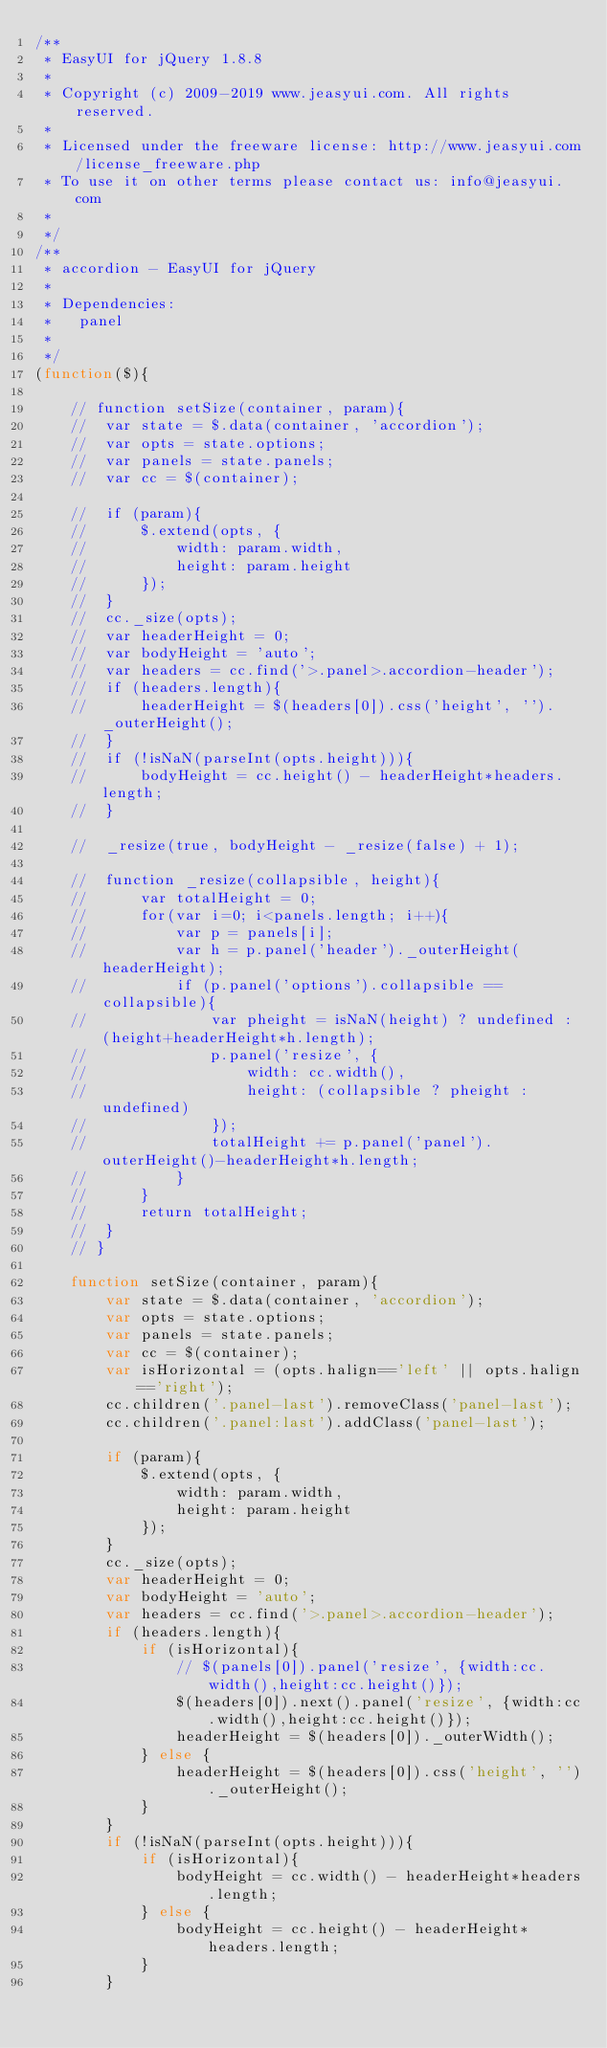<code> <loc_0><loc_0><loc_500><loc_500><_JavaScript_>/**
 * EasyUI for jQuery 1.8.8
 * 
 * Copyright (c) 2009-2019 www.jeasyui.com. All rights reserved.
 *
 * Licensed under the freeware license: http://www.jeasyui.com/license_freeware.php
 * To use it on other terms please contact us: info@jeasyui.com
 *
 */
/**
 * accordion - EasyUI for jQuery
 * 
 * Dependencies:
 * 	 panel
 * 
 */
(function($){
	
	// function setSize(container, param){
	// 	var state = $.data(container, 'accordion');
	// 	var opts = state.options;
	// 	var panels = state.panels;
	// 	var cc = $(container);
		
	// 	if (param){
	// 		$.extend(opts, {
	// 			width: param.width,
	// 			height: param.height
	// 		});
	// 	}
	// 	cc._size(opts);
	// 	var headerHeight = 0;
	// 	var bodyHeight = 'auto';
	// 	var headers = cc.find('>.panel>.accordion-header');
	// 	if (headers.length){
	// 		headerHeight = $(headers[0]).css('height', '')._outerHeight();
	// 	}
	// 	if (!isNaN(parseInt(opts.height))){
	// 		bodyHeight = cc.height() - headerHeight*headers.length;
	// 	}
		
	// 	_resize(true, bodyHeight - _resize(false) + 1);
		
	// 	function _resize(collapsible, height){
	// 		var totalHeight = 0;
	// 		for(var i=0; i<panels.length; i++){
	// 			var p = panels[i];
	// 			var h = p.panel('header')._outerHeight(headerHeight);
	// 			if (p.panel('options').collapsible == collapsible){
	// 				var pheight = isNaN(height) ? undefined : (height+headerHeight*h.length);
	// 				p.panel('resize', {
	// 					width: cc.width(),
	// 					height: (collapsible ? pheight : undefined)
	// 				});
	// 				totalHeight += p.panel('panel').outerHeight()-headerHeight*h.length;
	// 			}
	// 		}
	// 		return totalHeight;
	// 	}
	// }

	function setSize(container, param){
		var state = $.data(container, 'accordion');
		var opts = state.options;
		var panels = state.panels;
		var cc = $(container);
		var isHorizontal = (opts.halign=='left' || opts.halign=='right');
		cc.children('.panel-last').removeClass('panel-last');
		cc.children('.panel:last').addClass('panel-last');

		if (param){
			$.extend(opts, {
				width: param.width,
				height: param.height
			});
		}
		cc._size(opts);
		var headerHeight = 0;
		var bodyHeight = 'auto';
		var headers = cc.find('>.panel>.accordion-header');
		if (headers.length){
			if (isHorizontal){
				// $(panels[0]).panel('resize', {width:cc.width(),height:cc.height()});
				$(headers[0]).next().panel('resize', {width:cc.width(),height:cc.height()});
				headerHeight = $(headers[0])._outerWidth();
			} else {
				headerHeight = $(headers[0]).css('height', '')._outerHeight();
			}
		}
		if (!isNaN(parseInt(opts.height))){
			if (isHorizontal){
				bodyHeight = cc.width() - headerHeight*headers.length;
			} else {
				bodyHeight = cc.height() - headerHeight*headers.length;
			}
		}
</code> 